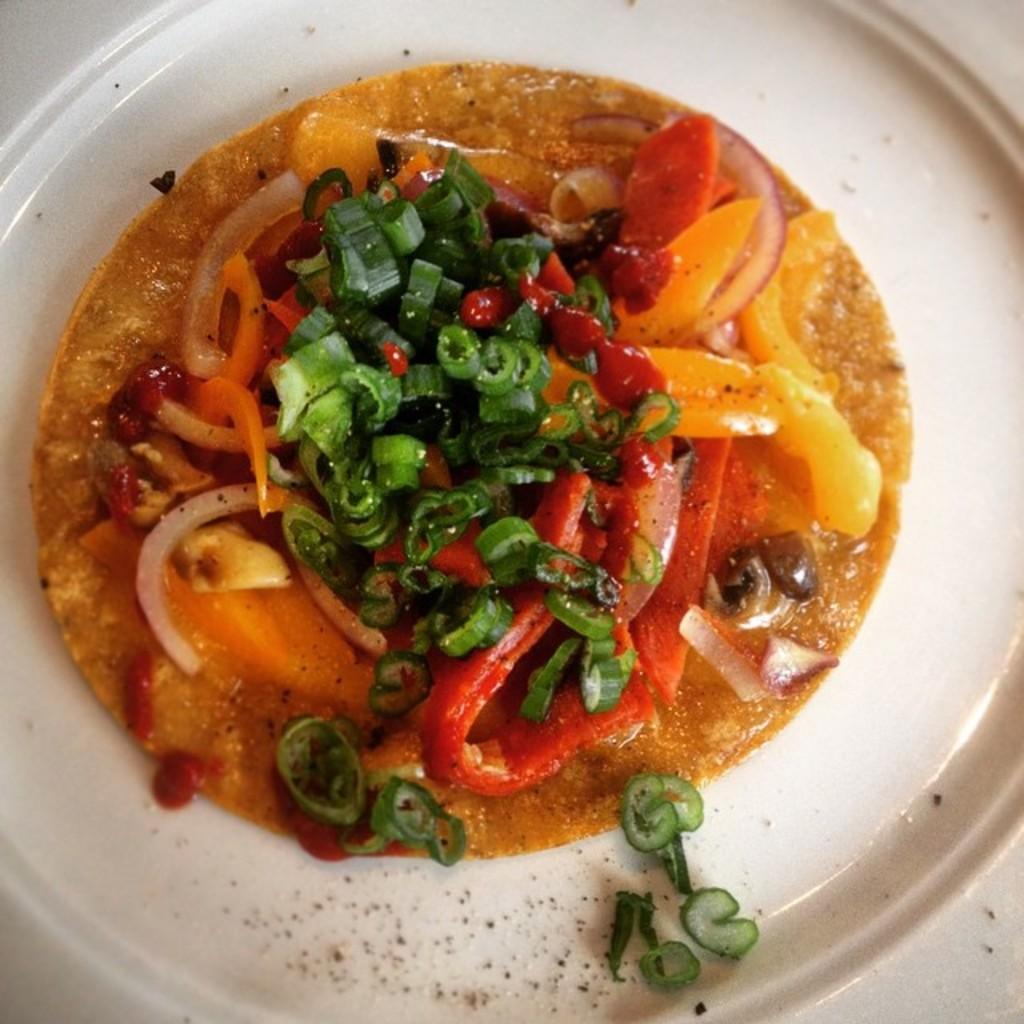Please provide a concise description of this image. In this picture, there is a bowl with some food. 